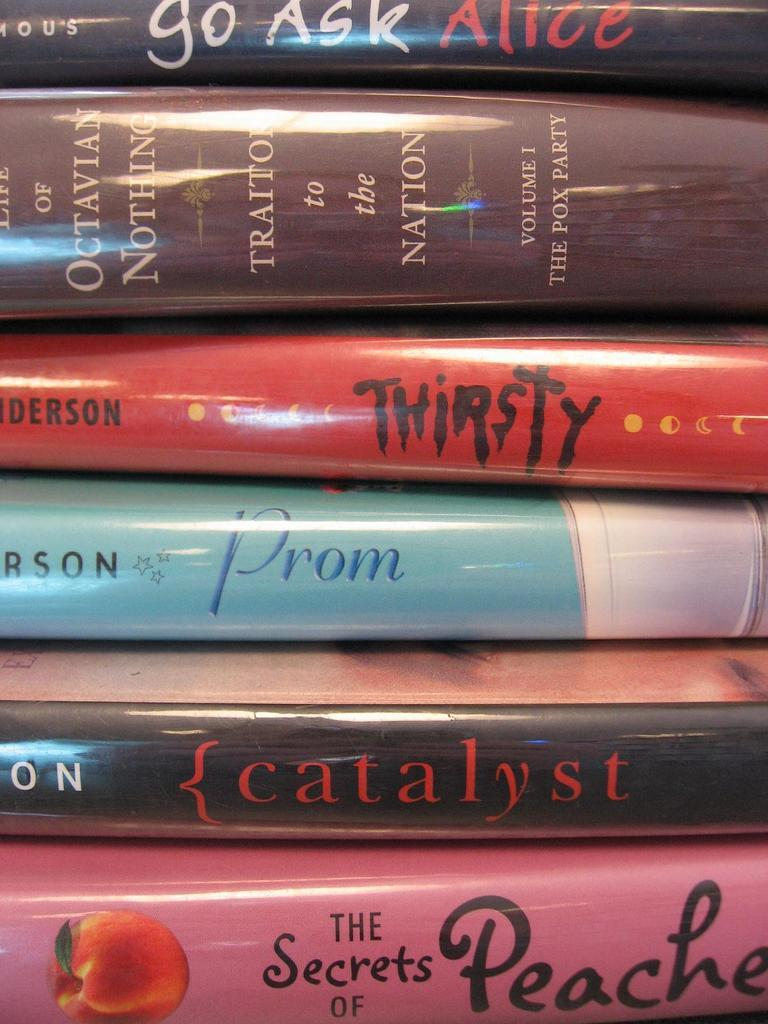<image>
Describe the image concisely. A stack of books includes one called Prom and another called Thirsty. 